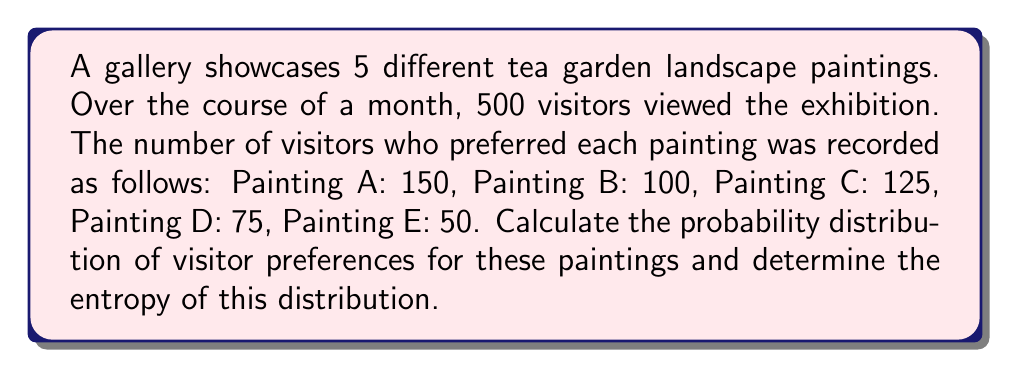Provide a solution to this math problem. To solve this problem, we'll follow these steps:

1. Calculate the probability for each painting:
   Let $N_i$ be the number of visitors preferring painting $i$, and $N$ the total number of visitors.
   $$P_i = \frac{N_i}{N}$$

   $P_A = \frac{150}{500} = 0.3$
   $P_B = \frac{100}{500} = 0.2$
   $P_C = \frac{125}{500} = 0.25$
   $P_D = \frac{75}{500} = 0.15$
   $P_E = \frac{50}{500} = 0.1$

2. Verify that the probabilities sum to 1:
   $$\sum_{i=A}^E P_i = 0.3 + 0.2 + 0.25 + 0.15 + 0.1 = 1$$

3. Calculate the entropy of the distribution:
   The entropy $S$ is given by:
   $$S = -k_B \sum_{i} P_i \ln(P_i)$$
   where $k_B$ is Boltzmann's constant. For our purposes, we can set $k_B = 1$.

   $$\begin{align}
   S &= -(0.3 \ln(0.3) + 0.2 \ln(0.2) + 0.25 \ln(0.25) + 0.15 \ln(0.15) + 0.1 \ln(0.1)) \\
   &\approx -(-0.3612 - 0.3219 - 0.3466 - 0.2849 - 0.2303) \\
   &\approx 1.5449
   \end{align}$$
Answer: Probability distribution: $P_A = 0.3$, $P_B = 0.2$, $P_C = 0.25$, $P_D = 0.15$, $P_E = 0.1$; Entropy: $S \approx 1.5449$ 